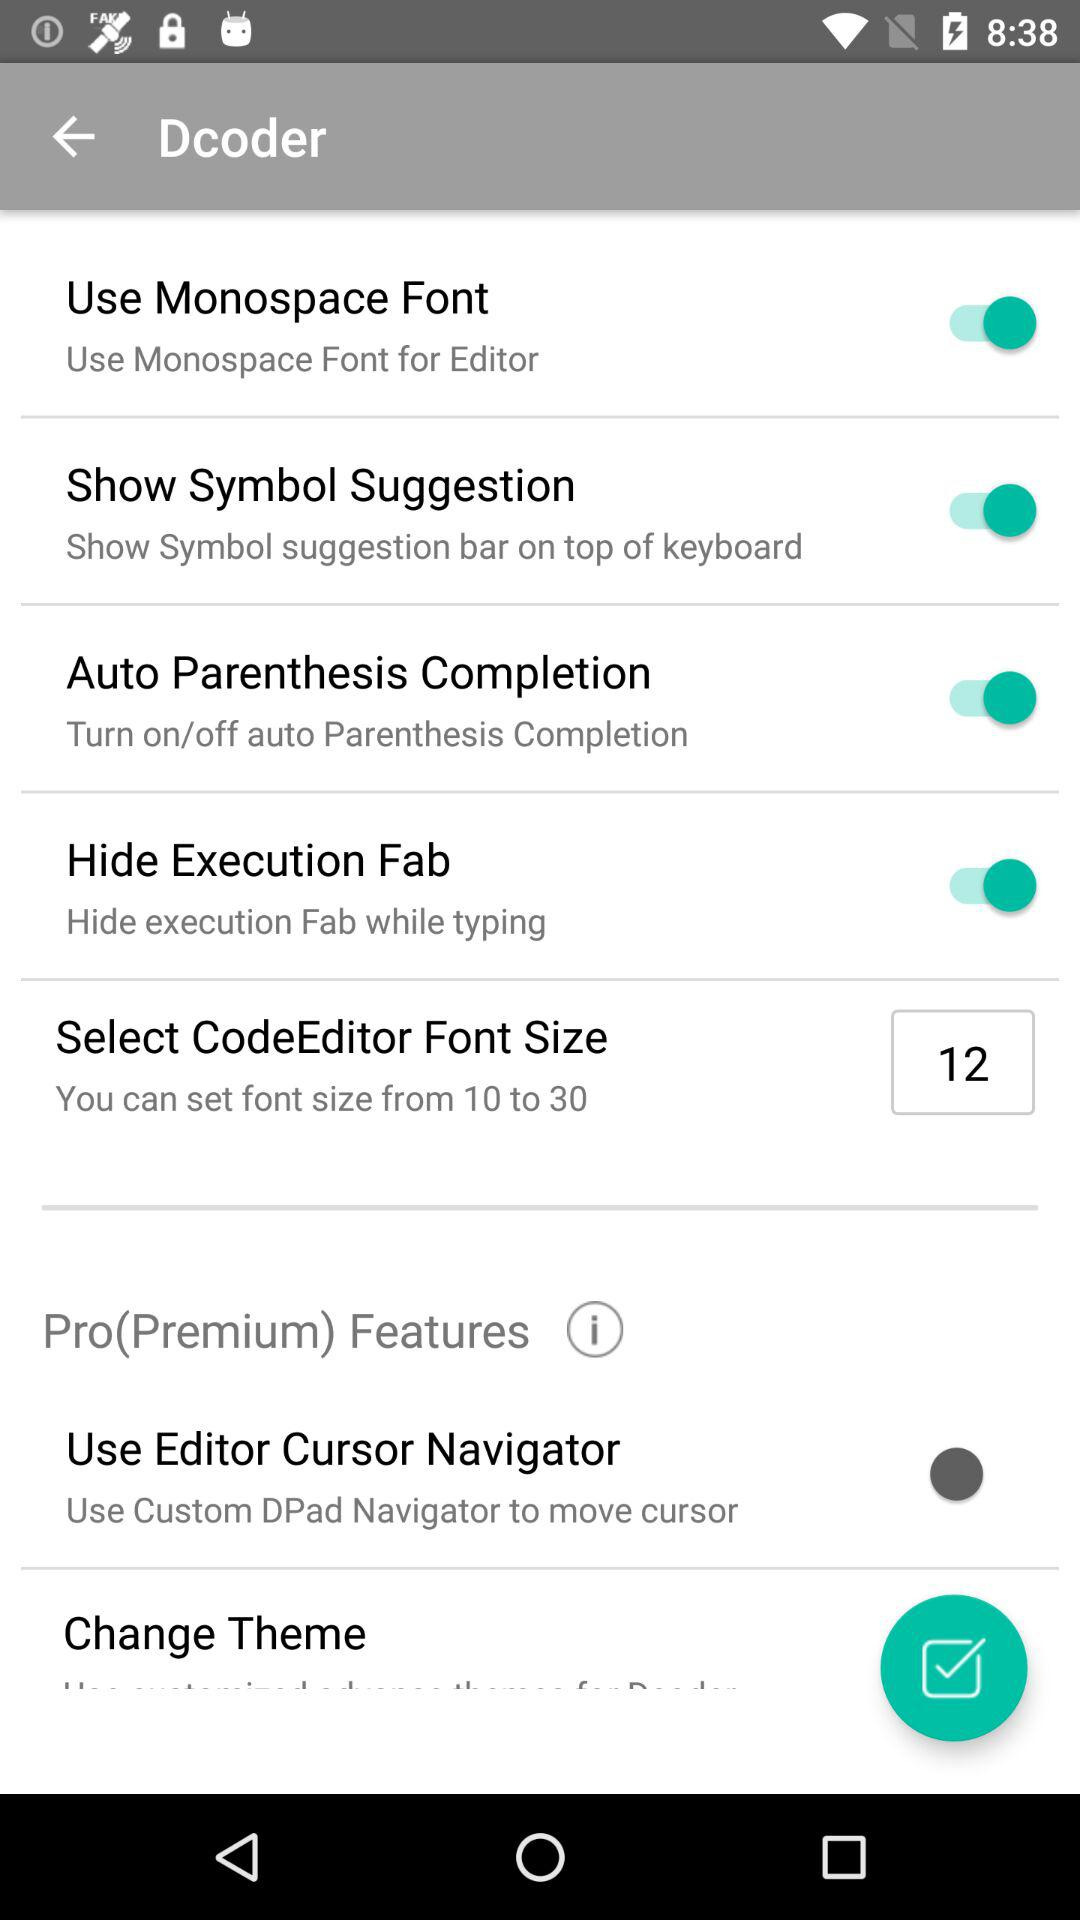What is the status of the "Hide Execution Fab"? The status of the "Hide Execution Fab" is "on". 